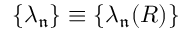<formula> <loc_0><loc_0><loc_500><loc_500>\{ \lambda _ { \mathfrak { n } } \} \equiv \{ \lambda _ { \mathfrak { n } } ( R ) \}</formula> 